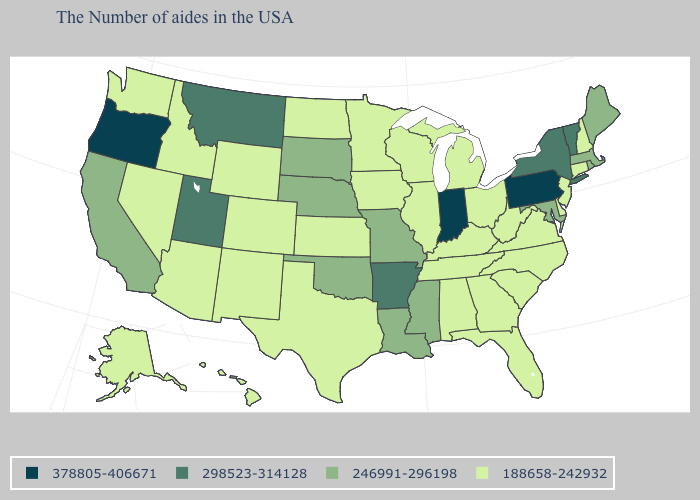Does Arkansas have the highest value in the South?
Give a very brief answer. Yes. Which states have the lowest value in the USA?
Keep it brief. New Hampshire, Connecticut, New Jersey, Delaware, Virginia, North Carolina, South Carolina, West Virginia, Ohio, Florida, Georgia, Michigan, Kentucky, Alabama, Tennessee, Wisconsin, Illinois, Minnesota, Iowa, Kansas, Texas, North Dakota, Wyoming, Colorado, New Mexico, Arizona, Idaho, Nevada, Washington, Alaska, Hawaii. Which states hav the highest value in the MidWest?
Answer briefly. Indiana. What is the value of Washington?
Write a very short answer. 188658-242932. Among the states that border Arkansas , which have the lowest value?
Quick response, please. Tennessee, Texas. What is the lowest value in the USA?
Answer briefly. 188658-242932. What is the value of Delaware?
Keep it brief. 188658-242932. Does Massachusetts have the lowest value in the USA?
Write a very short answer. No. Name the states that have a value in the range 378805-406671?
Give a very brief answer. Pennsylvania, Indiana, Oregon. Among the states that border Georgia , which have the highest value?
Answer briefly. North Carolina, South Carolina, Florida, Alabama, Tennessee. Name the states that have a value in the range 298523-314128?
Answer briefly. Vermont, New York, Arkansas, Utah, Montana. What is the value of South Carolina?
Short answer required. 188658-242932. Name the states that have a value in the range 188658-242932?
Short answer required. New Hampshire, Connecticut, New Jersey, Delaware, Virginia, North Carolina, South Carolina, West Virginia, Ohio, Florida, Georgia, Michigan, Kentucky, Alabama, Tennessee, Wisconsin, Illinois, Minnesota, Iowa, Kansas, Texas, North Dakota, Wyoming, Colorado, New Mexico, Arizona, Idaho, Nevada, Washington, Alaska, Hawaii. What is the lowest value in states that border Florida?
Write a very short answer. 188658-242932. What is the lowest value in states that border Louisiana?
Quick response, please. 188658-242932. 